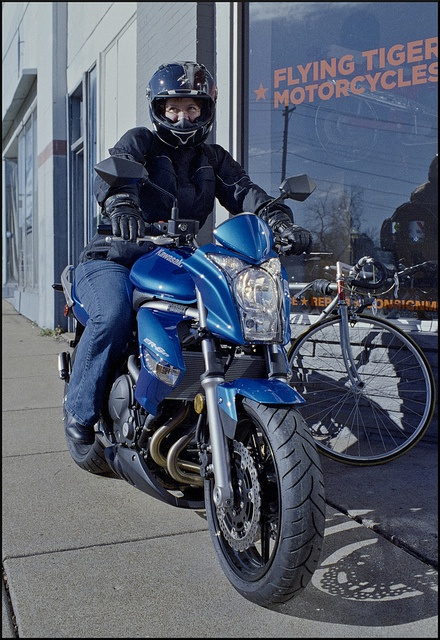Describe the objects in this image and their specific colors. I can see motorcycle in black, gray, navy, and darkgray tones, people in black, gray, and navy tones, and bicycle in black, darkgray, and gray tones in this image. 